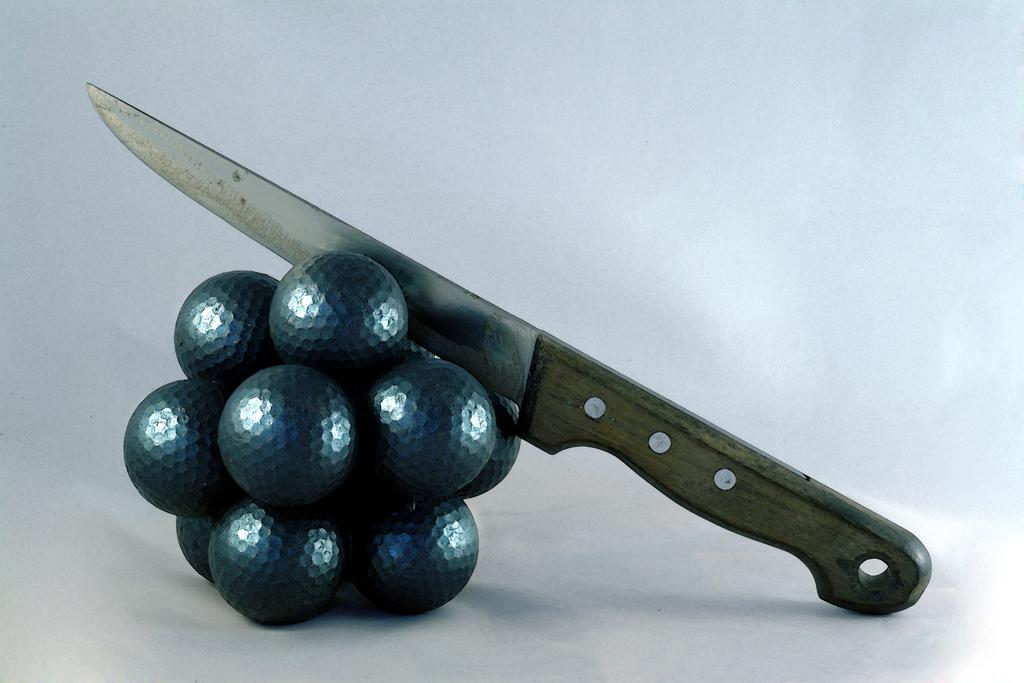What object is present in the image that is typically used for cutting? There is a knife in the image. What is the knife placed among in the image? The knife is placed among artificial grapes. Where are the artificial grapes and knife located in the image? The artificial grapes and knife are placed on a surface. What color is the background of the image? The background of the image is white. How many ladybugs can be seen crawling on the knife in the image? There are no ladybugs present in the image; it only features a knife and artificial grapes. What level of comfort does the knife provide in the image? The image does not convey any information about the comfort level provided by the knife, as it is an inanimate object. 